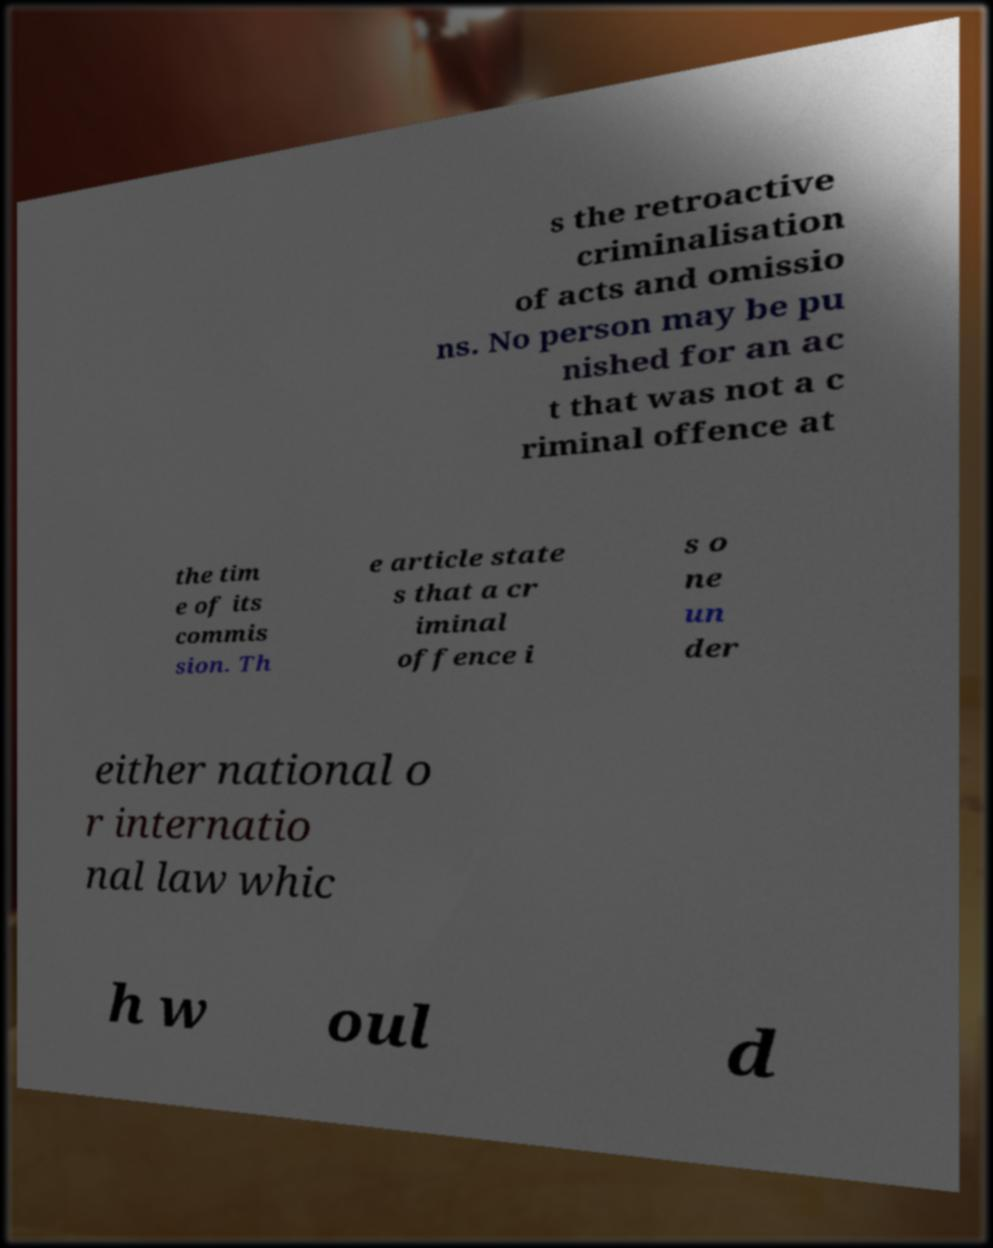I need the written content from this picture converted into text. Can you do that? s the retroactive criminalisation of acts and omissio ns. No person may be pu nished for an ac t that was not a c riminal offence at the tim e of its commis sion. Th e article state s that a cr iminal offence i s o ne un der either national o r internatio nal law whic h w oul d 